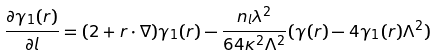<formula> <loc_0><loc_0><loc_500><loc_500>\frac { \partial \gamma _ { 1 } ( r ) } { \partial l } = ( 2 + { r } \cdot \nabla ) \gamma _ { 1 } ( r ) - \frac { n _ { l } \lambda ^ { 2 } } { 6 4 \kappa ^ { 2 } \Lambda ^ { 2 } } ( \gamma ( r ) - 4 \gamma _ { 1 } ( r ) \Lambda ^ { 2 } )</formula> 